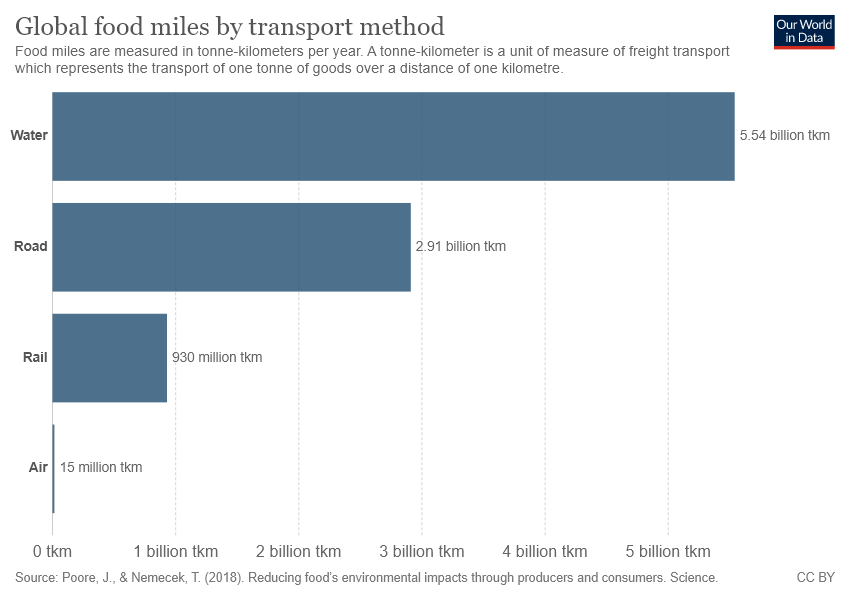Outline some significant characteristics in this image. The Global Food Miles value for road transport is 2.91, indicating the distance food travels from the farm to the consumer when transported by road. The average distance that global food travels by water and road is greater than 4 billion kilometers. 